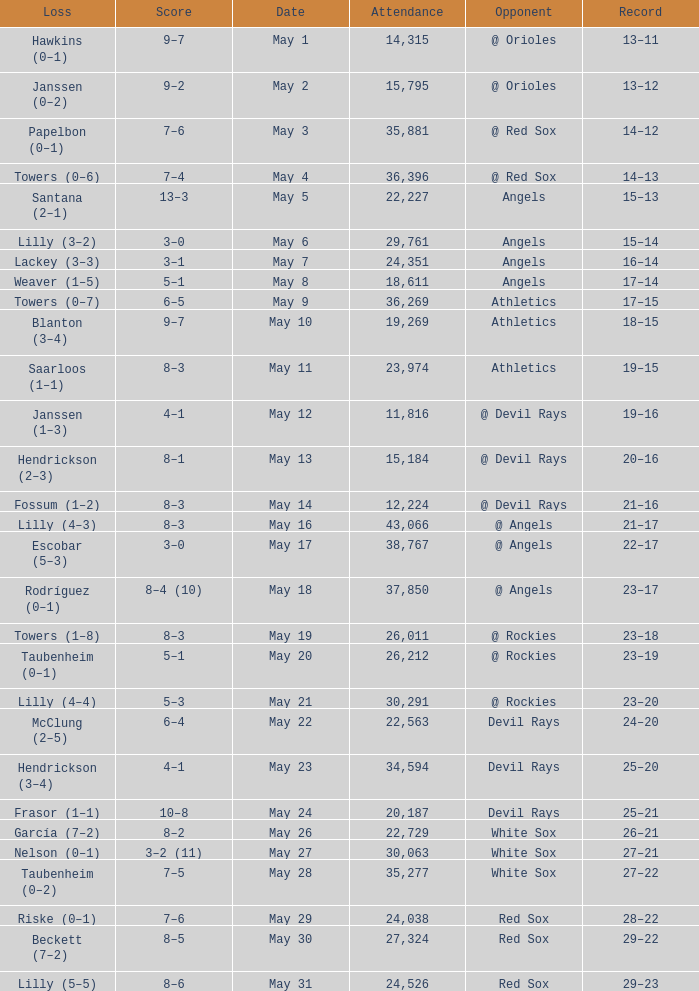When the team had their record of 16–14, what was the total attendance? 1.0. I'm looking to parse the entire table for insights. Could you assist me with that? {'header': ['Loss', 'Score', 'Date', 'Attendance', 'Opponent', 'Record'], 'rows': [['Hawkins (0–1)', '9–7', 'May 1', '14,315', '@ Orioles', '13–11'], ['Janssen (0–2)', '9–2', 'May 2', '15,795', '@ Orioles', '13–12'], ['Papelbon (0–1)', '7–6', 'May 3', '35,881', '@ Red Sox', '14–12'], ['Towers (0–6)', '7–4', 'May 4', '36,396', '@ Red Sox', '14–13'], ['Santana (2–1)', '13–3', 'May 5', '22,227', 'Angels', '15–13'], ['Lilly (3–2)', '3–0', 'May 6', '29,761', 'Angels', '15–14'], ['Lackey (3–3)', '3–1', 'May 7', '24,351', 'Angels', '16–14'], ['Weaver (1–5)', '5–1', 'May 8', '18,611', 'Angels', '17–14'], ['Towers (0–7)', '6–5', 'May 9', '36,269', 'Athletics', '17–15'], ['Blanton (3–4)', '9–7', 'May 10', '19,269', 'Athletics', '18–15'], ['Saarloos (1–1)', '8–3', 'May 11', '23,974', 'Athletics', '19–15'], ['Janssen (1–3)', '4–1', 'May 12', '11,816', '@ Devil Rays', '19–16'], ['Hendrickson (2–3)', '8–1', 'May 13', '15,184', '@ Devil Rays', '20–16'], ['Fossum (1–2)', '8–3', 'May 14', '12,224', '@ Devil Rays', '21–16'], ['Lilly (4–3)', '8–3', 'May 16', '43,066', '@ Angels', '21–17'], ['Escobar (5–3)', '3–0', 'May 17', '38,767', '@ Angels', '22–17'], ['Rodríguez (0–1)', '8–4 (10)', 'May 18', '37,850', '@ Angels', '23–17'], ['Towers (1–8)', '8–3', 'May 19', '26,011', '@ Rockies', '23–18'], ['Taubenheim (0–1)', '5–1', 'May 20', '26,212', '@ Rockies', '23–19'], ['Lilly (4–4)', '5–3', 'May 21', '30,291', '@ Rockies', '23–20'], ['McClung (2–5)', '6–4', 'May 22', '22,563', 'Devil Rays', '24–20'], ['Hendrickson (3–4)', '4–1', 'May 23', '34,594', 'Devil Rays', '25–20'], ['Frasor (1–1)', '10–8', 'May 24', '20,187', 'Devil Rays', '25–21'], ['García (7–2)', '8–2', 'May 26', '22,729', 'White Sox', '26–21'], ['Nelson (0–1)', '3–2 (11)', 'May 27', '30,063', 'White Sox', '27–21'], ['Taubenheim (0–2)', '7–5', 'May 28', '35,277', 'White Sox', '27–22'], ['Riske (0–1)', '7–6', 'May 29', '24,038', 'Red Sox', '28–22'], ['Beckett (7–2)', '8–5', 'May 30', '27,324', 'Red Sox', '29–22'], ['Lilly (5–5)', '8–6', 'May 31', '24,526', 'Red Sox', '29–23']]} 